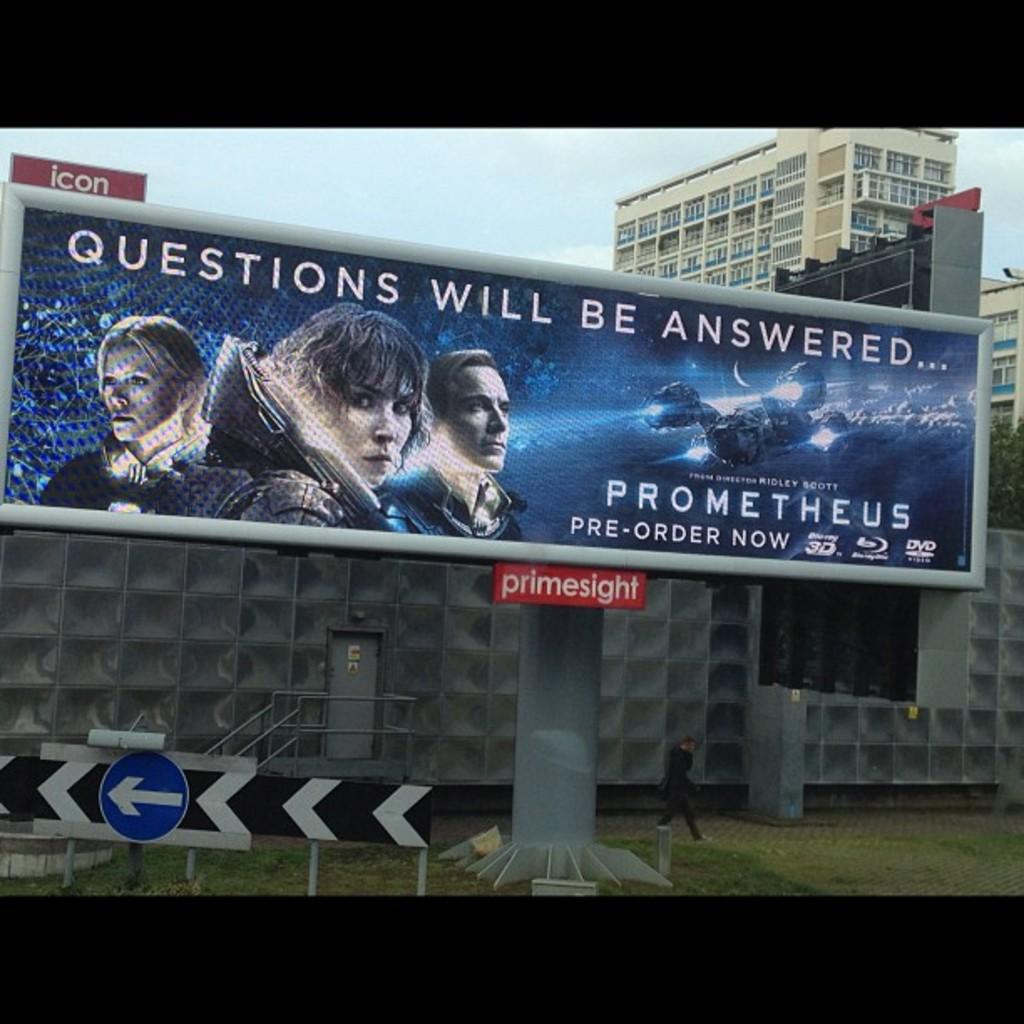What movie is advertised for pre-order?
Provide a succinct answer. Prometheus. What will be answered, according to this movie poster?
Your answer should be very brief. Questions. 